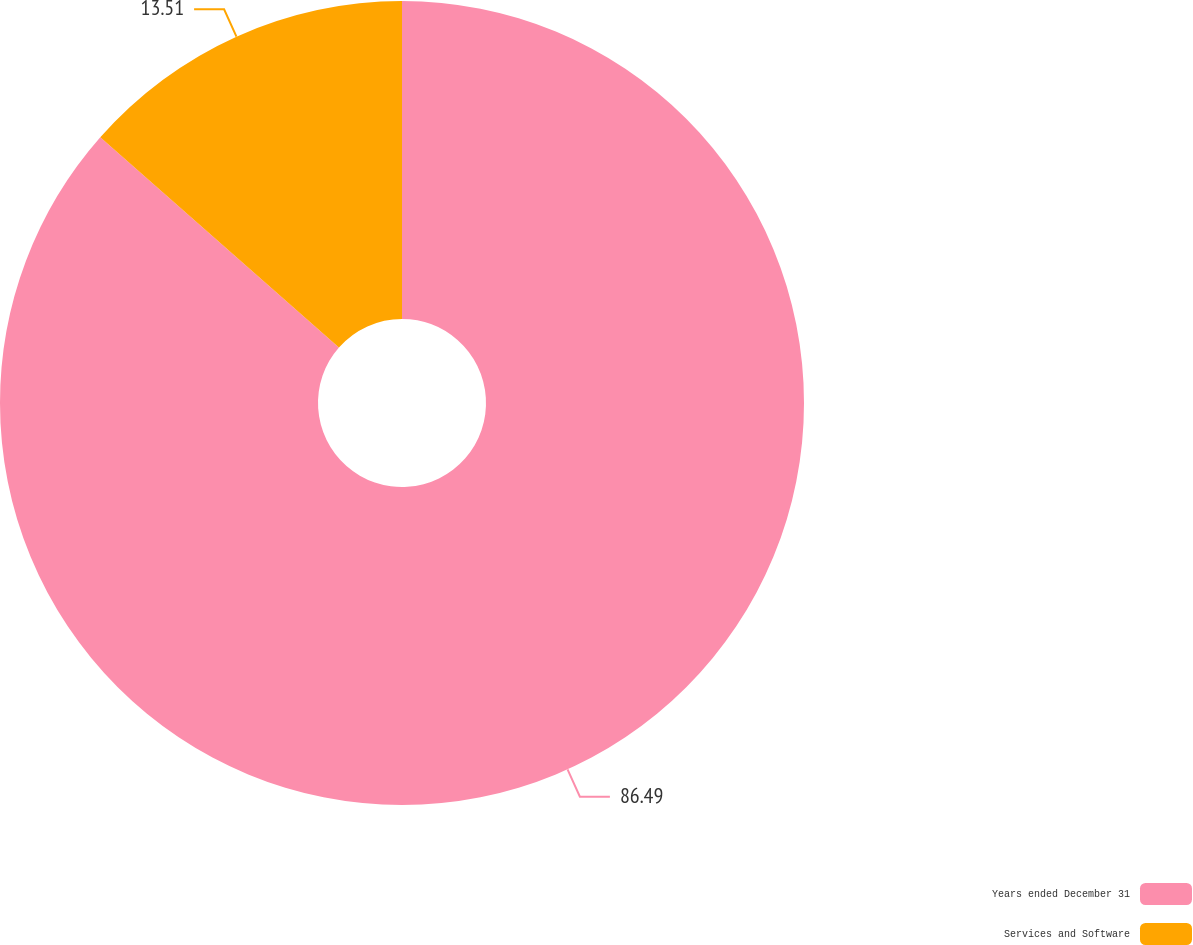Convert chart to OTSL. <chart><loc_0><loc_0><loc_500><loc_500><pie_chart><fcel>Years ended December 31<fcel>Services and Software<nl><fcel>86.49%<fcel>13.51%<nl></chart> 